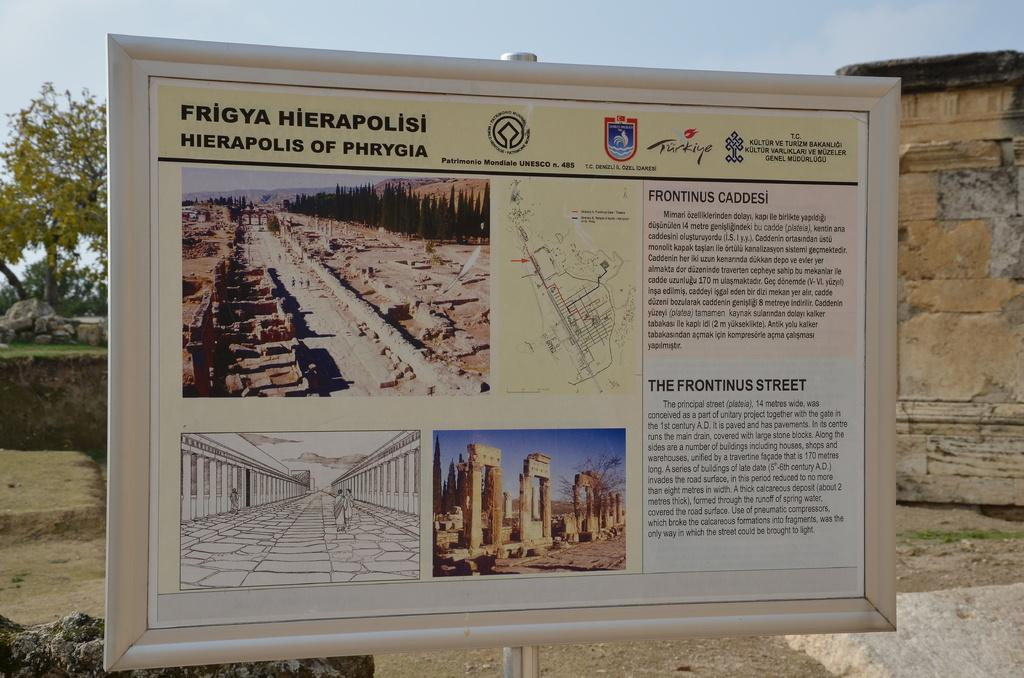Provide a one-sentence caption for the provided image. sign post that describes the Frigya Hierapolisis of Phrygia. 